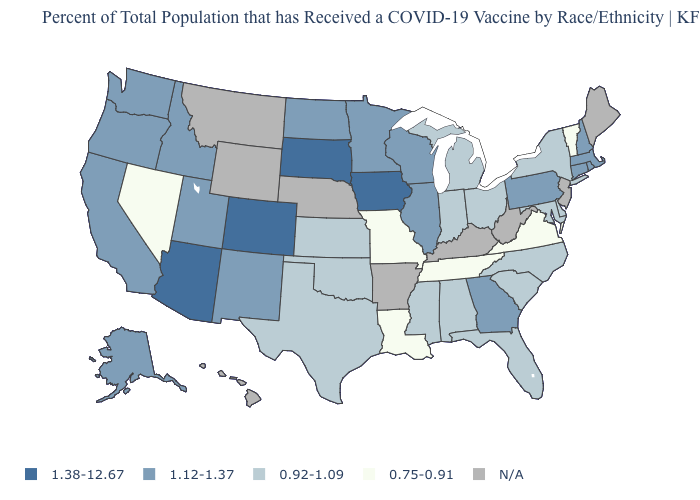Among the states that border Michigan , which have the highest value?
Give a very brief answer. Wisconsin. Name the states that have a value in the range 0.75-0.91?
Be succinct. Louisiana, Missouri, Nevada, Tennessee, Vermont, Virginia. What is the value of Vermont?
Be succinct. 0.75-0.91. How many symbols are there in the legend?
Quick response, please. 5. What is the lowest value in the USA?
Give a very brief answer. 0.75-0.91. What is the value of Arizona?
Answer briefly. 1.38-12.67. What is the value of Alaska?
Write a very short answer. 1.12-1.37. Among the states that border Michigan , does Ohio have the lowest value?
Short answer required. Yes. What is the lowest value in the South?
Answer briefly. 0.75-0.91. What is the value of Kansas?
Short answer required. 0.92-1.09. Name the states that have a value in the range N/A?
Concise answer only. Arkansas, Hawaii, Kentucky, Maine, Montana, Nebraska, New Jersey, West Virginia, Wyoming. Which states have the lowest value in the South?
Write a very short answer. Louisiana, Tennessee, Virginia. Name the states that have a value in the range 1.38-12.67?
Keep it brief. Arizona, Colorado, Iowa, South Dakota. What is the highest value in states that border Connecticut?
Answer briefly. 1.12-1.37. How many symbols are there in the legend?
Short answer required. 5. 